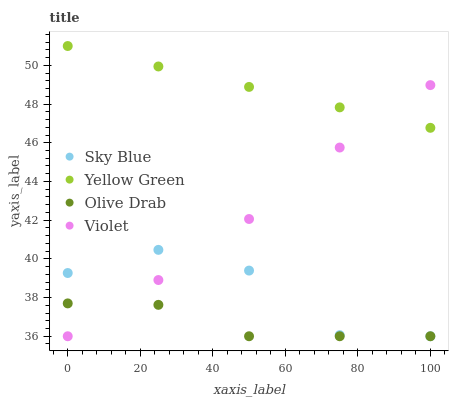Does Olive Drab have the minimum area under the curve?
Answer yes or no. Yes. Does Yellow Green have the maximum area under the curve?
Answer yes or no. Yes. Does Yellow Green have the minimum area under the curve?
Answer yes or no. No. Does Olive Drab have the maximum area under the curve?
Answer yes or no. No. Is Yellow Green the smoothest?
Answer yes or no. Yes. Is Sky Blue the roughest?
Answer yes or no. Yes. Is Olive Drab the smoothest?
Answer yes or no. No. Is Olive Drab the roughest?
Answer yes or no. No. Does Sky Blue have the lowest value?
Answer yes or no. Yes. Does Yellow Green have the lowest value?
Answer yes or no. No. Does Yellow Green have the highest value?
Answer yes or no. Yes. Does Olive Drab have the highest value?
Answer yes or no. No. Is Olive Drab less than Yellow Green?
Answer yes or no. Yes. Is Yellow Green greater than Sky Blue?
Answer yes or no. Yes. Does Yellow Green intersect Violet?
Answer yes or no. Yes. Is Yellow Green less than Violet?
Answer yes or no. No. Is Yellow Green greater than Violet?
Answer yes or no. No. Does Olive Drab intersect Yellow Green?
Answer yes or no. No. 